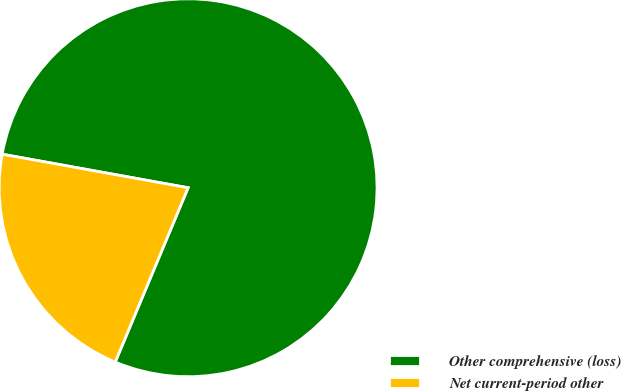<chart> <loc_0><loc_0><loc_500><loc_500><pie_chart><fcel>Other comprehensive (loss)<fcel>Net current-period other<nl><fcel>78.46%<fcel>21.54%<nl></chart> 